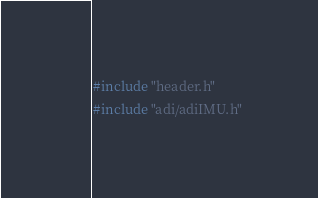Convert code to text. <code><loc_0><loc_0><loc_500><loc_500><_C++_>#include "header.h"
#include "adi/adiIMU.h"

</code> 